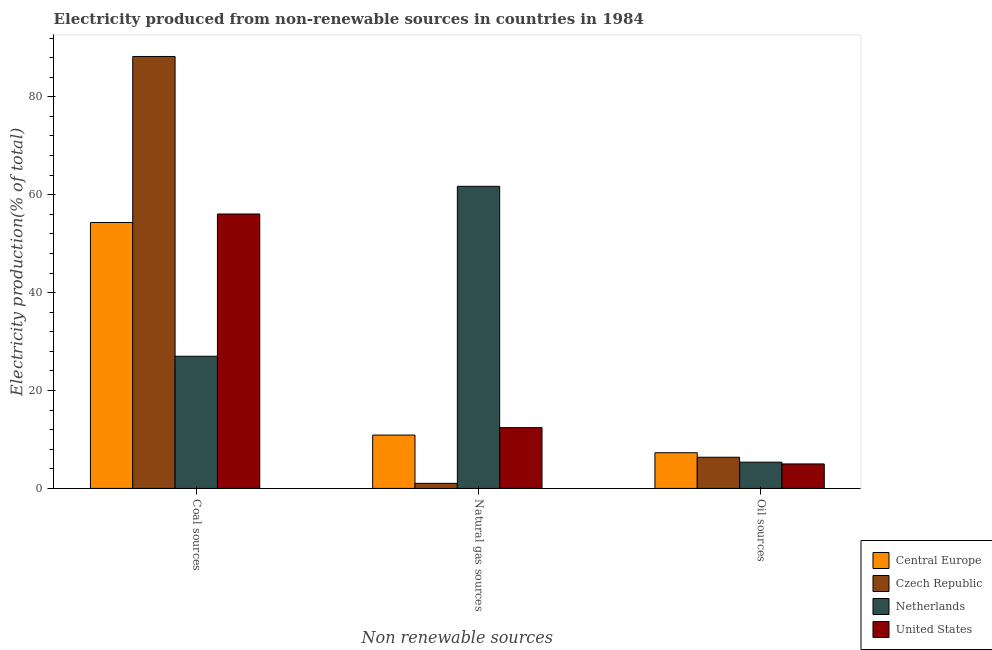Are the number of bars on each tick of the X-axis equal?
Your answer should be compact. Yes. What is the label of the 2nd group of bars from the left?
Your response must be concise. Natural gas sources. What is the percentage of electricity produced by natural gas in Netherlands?
Keep it short and to the point. 61.71. Across all countries, what is the maximum percentage of electricity produced by oil sources?
Give a very brief answer. 7.29. Across all countries, what is the minimum percentage of electricity produced by oil sources?
Offer a terse response. 5. In which country was the percentage of electricity produced by coal maximum?
Keep it short and to the point. Czech Republic. In which country was the percentage of electricity produced by natural gas minimum?
Keep it short and to the point. Czech Republic. What is the total percentage of electricity produced by coal in the graph?
Your response must be concise. 225.59. What is the difference between the percentage of electricity produced by coal in Netherlands and that in Central Europe?
Your response must be concise. -27.32. What is the difference between the percentage of electricity produced by natural gas in Czech Republic and the percentage of electricity produced by coal in Central Europe?
Your answer should be very brief. -53.28. What is the average percentage of electricity produced by coal per country?
Provide a succinct answer. 56.4. What is the difference between the percentage of electricity produced by oil sources and percentage of electricity produced by natural gas in Czech Republic?
Ensure brevity in your answer.  5.33. What is the ratio of the percentage of electricity produced by coal in Central Europe to that in United States?
Your response must be concise. 0.97. Is the percentage of electricity produced by oil sources in United States less than that in Netherlands?
Ensure brevity in your answer.  Yes. Is the difference between the percentage of electricity produced by oil sources in Netherlands and Czech Republic greater than the difference between the percentage of electricity produced by coal in Netherlands and Czech Republic?
Ensure brevity in your answer.  Yes. What is the difference between the highest and the second highest percentage of electricity produced by natural gas?
Provide a short and direct response. 49.29. What is the difference between the highest and the lowest percentage of electricity produced by coal?
Make the answer very short. 61.23. In how many countries, is the percentage of electricity produced by oil sources greater than the average percentage of electricity produced by oil sources taken over all countries?
Offer a terse response. 2. What does the 4th bar from the left in Oil sources represents?
Your answer should be compact. United States. What does the 4th bar from the right in Natural gas sources represents?
Offer a terse response. Central Europe. How many countries are there in the graph?
Keep it short and to the point. 4. What is the difference between two consecutive major ticks on the Y-axis?
Your answer should be compact. 20. Does the graph contain any zero values?
Your answer should be compact. No. How many legend labels are there?
Provide a short and direct response. 4. How are the legend labels stacked?
Your answer should be compact. Vertical. What is the title of the graph?
Ensure brevity in your answer.  Electricity produced from non-renewable sources in countries in 1984. What is the label or title of the X-axis?
Give a very brief answer. Non renewable sources. What is the Electricity production(% of total) of Central Europe in Coal sources?
Make the answer very short. 54.31. What is the Electricity production(% of total) of Czech Republic in Coal sources?
Offer a very short reply. 88.23. What is the Electricity production(% of total) in Netherlands in Coal sources?
Offer a terse response. 27. What is the Electricity production(% of total) in United States in Coal sources?
Offer a terse response. 56.05. What is the Electricity production(% of total) of Central Europe in Natural gas sources?
Your answer should be very brief. 10.9. What is the Electricity production(% of total) in Czech Republic in Natural gas sources?
Give a very brief answer. 1.03. What is the Electricity production(% of total) of Netherlands in Natural gas sources?
Keep it short and to the point. 61.71. What is the Electricity production(% of total) in United States in Natural gas sources?
Your response must be concise. 12.42. What is the Electricity production(% of total) in Central Europe in Oil sources?
Your answer should be compact. 7.29. What is the Electricity production(% of total) of Czech Republic in Oil sources?
Ensure brevity in your answer.  6.37. What is the Electricity production(% of total) in Netherlands in Oil sources?
Your answer should be very brief. 5.36. What is the Electricity production(% of total) in United States in Oil sources?
Keep it short and to the point. 5. Across all Non renewable sources, what is the maximum Electricity production(% of total) of Central Europe?
Your response must be concise. 54.31. Across all Non renewable sources, what is the maximum Electricity production(% of total) of Czech Republic?
Your answer should be very brief. 88.23. Across all Non renewable sources, what is the maximum Electricity production(% of total) in Netherlands?
Keep it short and to the point. 61.71. Across all Non renewable sources, what is the maximum Electricity production(% of total) in United States?
Give a very brief answer. 56.05. Across all Non renewable sources, what is the minimum Electricity production(% of total) in Central Europe?
Offer a terse response. 7.29. Across all Non renewable sources, what is the minimum Electricity production(% of total) of Czech Republic?
Offer a terse response. 1.03. Across all Non renewable sources, what is the minimum Electricity production(% of total) of Netherlands?
Your response must be concise. 5.36. Across all Non renewable sources, what is the minimum Electricity production(% of total) in United States?
Provide a short and direct response. 5. What is the total Electricity production(% of total) of Central Europe in the graph?
Your answer should be very brief. 72.5. What is the total Electricity production(% of total) of Czech Republic in the graph?
Your answer should be very brief. 95.63. What is the total Electricity production(% of total) of Netherlands in the graph?
Your answer should be very brief. 94.06. What is the total Electricity production(% of total) in United States in the graph?
Your answer should be very brief. 73.47. What is the difference between the Electricity production(% of total) of Central Europe in Coal sources and that in Natural gas sources?
Make the answer very short. 43.42. What is the difference between the Electricity production(% of total) of Czech Republic in Coal sources and that in Natural gas sources?
Give a very brief answer. 87.19. What is the difference between the Electricity production(% of total) in Netherlands in Coal sources and that in Natural gas sources?
Provide a short and direct response. -34.71. What is the difference between the Electricity production(% of total) of United States in Coal sources and that in Natural gas sources?
Give a very brief answer. 43.64. What is the difference between the Electricity production(% of total) in Central Europe in Coal sources and that in Oil sources?
Your answer should be compact. 47.03. What is the difference between the Electricity production(% of total) of Czech Republic in Coal sources and that in Oil sources?
Offer a very short reply. 81.86. What is the difference between the Electricity production(% of total) of Netherlands in Coal sources and that in Oil sources?
Give a very brief answer. 21.64. What is the difference between the Electricity production(% of total) in United States in Coal sources and that in Oil sources?
Ensure brevity in your answer.  51.05. What is the difference between the Electricity production(% of total) in Central Europe in Natural gas sources and that in Oil sources?
Offer a terse response. 3.61. What is the difference between the Electricity production(% of total) in Czech Republic in Natural gas sources and that in Oil sources?
Your answer should be compact. -5.33. What is the difference between the Electricity production(% of total) of Netherlands in Natural gas sources and that in Oil sources?
Provide a succinct answer. 56.35. What is the difference between the Electricity production(% of total) of United States in Natural gas sources and that in Oil sources?
Offer a terse response. 7.41. What is the difference between the Electricity production(% of total) in Central Europe in Coal sources and the Electricity production(% of total) in Czech Republic in Natural gas sources?
Offer a very short reply. 53.28. What is the difference between the Electricity production(% of total) of Central Europe in Coal sources and the Electricity production(% of total) of Netherlands in Natural gas sources?
Offer a terse response. -7.39. What is the difference between the Electricity production(% of total) of Central Europe in Coal sources and the Electricity production(% of total) of United States in Natural gas sources?
Provide a short and direct response. 41.9. What is the difference between the Electricity production(% of total) in Czech Republic in Coal sources and the Electricity production(% of total) in Netherlands in Natural gas sources?
Make the answer very short. 26.52. What is the difference between the Electricity production(% of total) in Czech Republic in Coal sources and the Electricity production(% of total) in United States in Natural gas sources?
Your answer should be compact. 75.81. What is the difference between the Electricity production(% of total) in Netherlands in Coal sources and the Electricity production(% of total) in United States in Natural gas sources?
Offer a terse response. 14.58. What is the difference between the Electricity production(% of total) of Central Europe in Coal sources and the Electricity production(% of total) of Czech Republic in Oil sources?
Give a very brief answer. 47.95. What is the difference between the Electricity production(% of total) of Central Europe in Coal sources and the Electricity production(% of total) of Netherlands in Oil sources?
Your answer should be very brief. 48.96. What is the difference between the Electricity production(% of total) of Central Europe in Coal sources and the Electricity production(% of total) of United States in Oil sources?
Provide a succinct answer. 49.31. What is the difference between the Electricity production(% of total) of Czech Republic in Coal sources and the Electricity production(% of total) of Netherlands in Oil sources?
Your answer should be very brief. 82.87. What is the difference between the Electricity production(% of total) in Czech Republic in Coal sources and the Electricity production(% of total) in United States in Oil sources?
Your response must be concise. 83.23. What is the difference between the Electricity production(% of total) in Netherlands in Coal sources and the Electricity production(% of total) in United States in Oil sources?
Give a very brief answer. 21.99. What is the difference between the Electricity production(% of total) of Central Europe in Natural gas sources and the Electricity production(% of total) of Czech Republic in Oil sources?
Offer a very short reply. 4.53. What is the difference between the Electricity production(% of total) in Central Europe in Natural gas sources and the Electricity production(% of total) in Netherlands in Oil sources?
Provide a succinct answer. 5.54. What is the difference between the Electricity production(% of total) in Central Europe in Natural gas sources and the Electricity production(% of total) in United States in Oil sources?
Keep it short and to the point. 5.89. What is the difference between the Electricity production(% of total) in Czech Republic in Natural gas sources and the Electricity production(% of total) in Netherlands in Oil sources?
Offer a terse response. -4.32. What is the difference between the Electricity production(% of total) of Czech Republic in Natural gas sources and the Electricity production(% of total) of United States in Oil sources?
Make the answer very short. -3.97. What is the difference between the Electricity production(% of total) in Netherlands in Natural gas sources and the Electricity production(% of total) in United States in Oil sources?
Your response must be concise. 56.7. What is the average Electricity production(% of total) in Central Europe per Non renewable sources?
Give a very brief answer. 24.17. What is the average Electricity production(% of total) of Czech Republic per Non renewable sources?
Give a very brief answer. 31.88. What is the average Electricity production(% of total) in Netherlands per Non renewable sources?
Provide a short and direct response. 31.35. What is the average Electricity production(% of total) of United States per Non renewable sources?
Your answer should be compact. 24.49. What is the difference between the Electricity production(% of total) of Central Europe and Electricity production(% of total) of Czech Republic in Coal sources?
Provide a succinct answer. -33.91. What is the difference between the Electricity production(% of total) in Central Europe and Electricity production(% of total) in Netherlands in Coal sources?
Ensure brevity in your answer.  27.32. What is the difference between the Electricity production(% of total) of Central Europe and Electricity production(% of total) of United States in Coal sources?
Your answer should be compact. -1.74. What is the difference between the Electricity production(% of total) in Czech Republic and Electricity production(% of total) in Netherlands in Coal sources?
Provide a succinct answer. 61.23. What is the difference between the Electricity production(% of total) in Czech Republic and Electricity production(% of total) in United States in Coal sources?
Your answer should be compact. 32.17. What is the difference between the Electricity production(% of total) in Netherlands and Electricity production(% of total) in United States in Coal sources?
Provide a short and direct response. -29.06. What is the difference between the Electricity production(% of total) of Central Europe and Electricity production(% of total) of Czech Republic in Natural gas sources?
Ensure brevity in your answer.  9.86. What is the difference between the Electricity production(% of total) in Central Europe and Electricity production(% of total) in Netherlands in Natural gas sources?
Provide a succinct answer. -50.81. What is the difference between the Electricity production(% of total) of Central Europe and Electricity production(% of total) of United States in Natural gas sources?
Your response must be concise. -1.52. What is the difference between the Electricity production(% of total) in Czech Republic and Electricity production(% of total) in Netherlands in Natural gas sources?
Provide a short and direct response. -60.67. What is the difference between the Electricity production(% of total) of Czech Republic and Electricity production(% of total) of United States in Natural gas sources?
Your response must be concise. -11.38. What is the difference between the Electricity production(% of total) of Netherlands and Electricity production(% of total) of United States in Natural gas sources?
Keep it short and to the point. 49.29. What is the difference between the Electricity production(% of total) of Central Europe and Electricity production(% of total) of Czech Republic in Oil sources?
Your answer should be very brief. 0.92. What is the difference between the Electricity production(% of total) in Central Europe and Electricity production(% of total) in Netherlands in Oil sources?
Make the answer very short. 1.93. What is the difference between the Electricity production(% of total) in Central Europe and Electricity production(% of total) in United States in Oil sources?
Provide a succinct answer. 2.29. What is the difference between the Electricity production(% of total) of Czech Republic and Electricity production(% of total) of Netherlands in Oil sources?
Offer a very short reply. 1.01. What is the difference between the Electricity production(% of total) of Czech Republic and Electricity production(% of total) of United States in Oil sources?
Your response must be concise. 1.36. What is the difference between the Electricity production(% of total) of Netherlands and Electricity production(% of total) of United States in Oil sources?
Keep it short and to the point. 0.36. What is the ratio of the Electricity production(% of total) in Central Europe in Coal sources to that in Natural gas sources?
Give a very brief answer. 4.99. What is the ratio of the Electricity production(% of total) in Czech Republic in Coal sources to that in Natural gas sources?
Provide a succinct answer. 85.32. What is the ratio of the Electricity production(% of total) in Netherlands in Coal sources to that in Natural gas sources?
Offer a very short reply. 0.44. What is the ratio of the Electricity production(% of total) of United States in Coal sources to that in Natural gas sources?
Provide a succinct answer. 4.51. What is the ratio of the Electricity production(% of total) in Central Europe in Coal sources to that in Oil sources?
Give a very brief answer. 7.45. What is the ratio of the Electricity production(% of total) of Czech Republic in Coal sources to that in Oil sources?
Keep it short and to the point. 13.86. What is the ratio of the Electricity production(% of total) of Netherlands in Coal sources to that in Oil sources?
Give a very brief answer. 5.04. What is the ratio of the Electricity production(% of total) in United States in Coal sources to that in Oil sources?
Your answer should be very brief. 11.21. What is the ratio of the Electricity production(% of total) in Central Europe in Natural gas sources to that in Oil sources?
Provide a succinct answer. 1.5. What is the ratio of the Electricity production(% of total) of Czech Republic in Natural gas sources to that in Oil sources?
Your answer should be compact. 0.16. What is the ratio of the Electricity production(% of total) in Netherlands in Natural gas sources to that in Oil sources?
Your answer should be very brief. 11.52. What is the ratio of the Electricity production(% of total) in United States in Natural gas sources to that in Oil sources?
Your answer should be very brief. 2.48. What is the difference between the highest and the second highest Electricity production(% of total) in Central Europe?
Offer a terse response. 43.42. What is the difference between the highest and the second highest Electricity production(% of total) of Czech Republic?
Make the answer very short. 81.86. What is the difference between the highest and the second highest Electricity production(% of total) in Netherlands?
Ensure brevity in your answer.  34.71. What is the difference between the highest and the second highest Electricity production(% of total) in United States?
Give a very brief answer. 43.64. What is the difference between the highest and the lowest Electricity production(% of total) in Central Europe?
Your answer should be compact. 47.03. What is the difference between the highest and the lowest Electricity production(% of total) of Czech Republic?
Make the answer very short. 87.19. What is the difference between the highest and the lowest Electricity production(% of total) in Netherlands?
Your answer should be compact. 56.35. What is the difference between the highest and the lowest Electricity production(% of total) in United States?
Make the answer very short. 51.05. 